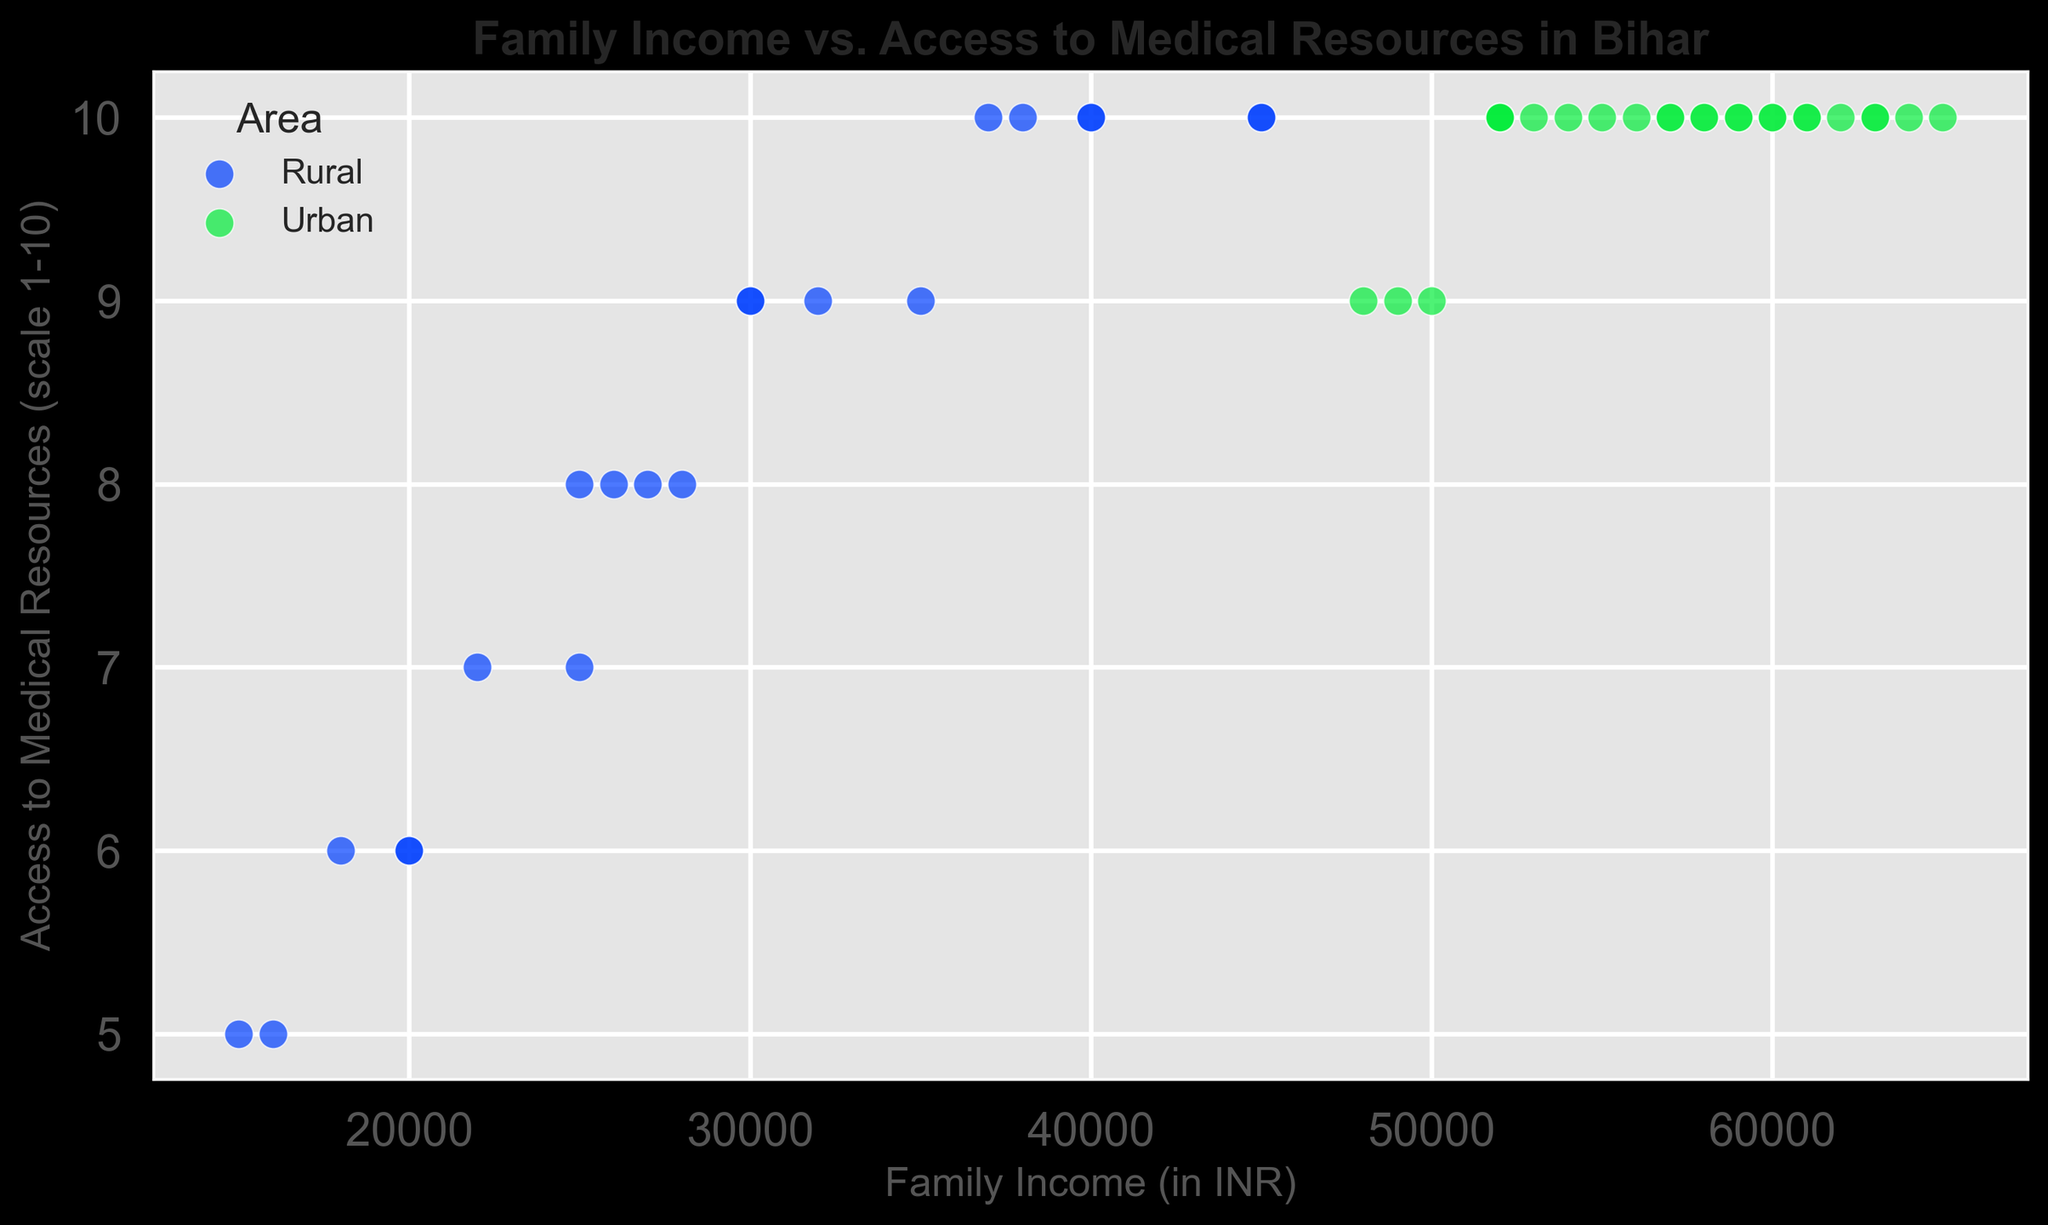What's the general trend between family income and access to medical resources in rural and urban areas? By observing the scatter plot, we can see that as family income increases, the access to medical resources increases as well. This pattern holds true for both rural and urban areas.
Answer: Positive correlation Do urban areas typically have high access to medical resources regardless of family income? Yes, the scatter plot shows that households in urban areas mostly have the highest rating of 10 for access to medical resources, even for varying family incomes.
Answer: Yes What is the difference in access to medical resources between a family earning INR 40,000 in a rural area and one in an urban area? From the scatter plot, a family with INR 40,000 income in a rural area has an access score of 10, while a family with the same income in an urban area has a score of 10. Therefore, there is no difference in this case.
Answer: No difference Compare the average access to medical resources for families in rural areas with INR 30,000 income and those in urban areas with INR 60,000 income. In rural areas, families with INR 30,000 income have an access score mostly around 9, while in urban areas, families with INR 60,000 income have an access score of 10.
Answer: Urban: 10, Rural: 9 Do any families in the 15,000-20,000 INR income range in rural areas have high access to medical resources? By looking at the scatter plot, families in the 15,000-20,000 INR income range in rural areas have access scores ranging from 5 to 6, which are relatively low.
Answer: No How many urban data points have less than full access (below a score of 10) to medical resources? By observing the scatter plot, there are a few urban data points (3 points) that have an access score of 9.
Answer: 3 What's the range of incomes in rural areas having the highest access to medical resources? Families in rural areas with the highest access scores (10) have incomes ranging from INR 37,000 to INR 45,000.
Answer: INR 37,000 to INR 45,000 Is there any overlap in the income levels of families from rural and urban areas with access to medical resources at levels 10? Yes, families from both rural and urban areas with incomes ranging from INR 37,000 to INR 65,000 have access levels of 10.
Answer: Yes Between rural and urban areas, which area shows a wider range of access to medical resources for different income levels? Rural areas show a wider range of access scores from 5 to 10, while urban areas mostly have scores of 10.
Answer: Rural areas Is the highest level of access to medical resources always associated with higher family income in rural areas? Not necessarily. In rural areas, even families with lower incomes (around INR 25,000 to INR 30,000) have relatively high access scores (around 8 to 9).
Answer: No 